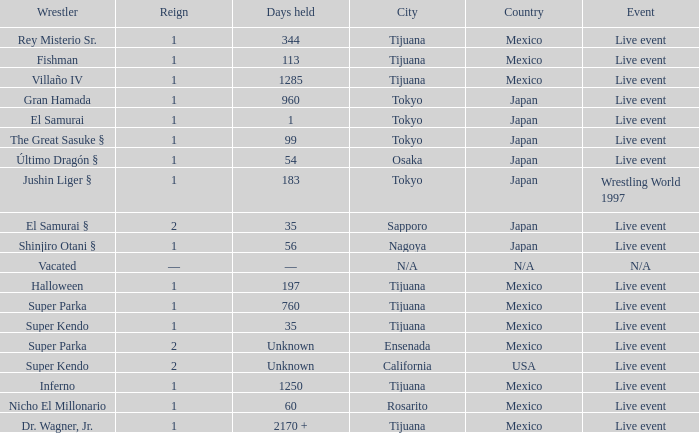Would you be able to parse every entry in this table? {'header': ['Wrestler', 'Reign', 'Days held', 'City', 'Country', 'Event'], 'rows': [['Rey Misterio Sr.', '1', '344', 'Tijuana', 'Mexico', 'Live event'], ['Fishman', '1', '113', 'Tijuana', 'Mexico', 'Live event'], ['Villaño IV', '1', '1285', 'Tijuana', 'Mexico', 'Live event'], ['Gran Hamada', '1', '960', 'Tokyo', 'Japan', 'Live event'], ['El Samurai', '1', '1', 'Tokyo', 'Japan', 'Live event'], ['The Great Sasuke §', '1', '99', 'Tokyo', 'Japan', 'Live event'], ['Último Dragón §', '1', '54', 'Osaka', 'Japan', 'Live event'], ['Jushin Liger §', '1', '183', 'Tokyo', 'Japan', 'Wrestling World 1997'], ['El Samurai §', '2', '35', 'Sapporo', 'Japan', 'Live event'], ['Shinjiro Otani §', '1', '56', 'Nagoya', 'Japan', 'Live event'], ['Vacated', '—', '—', 'N/A', 'N/A', 'N/A'], ['Halloween', '1', '197', 'Tijuana', 'Mexico', 'Live event'], ['Super Parka', '1', '760', 'Tijuana', 'Mexico', 'Live event'], ['Super Kendo', '1', '35', 'Tijuana', 'Mexico', 'Live event'], ['Super Parka', '2', 'Unknown', 'Ensenada', 'Mexico', 'Live event'], ['Super Kendo', '2', 'Unknown', 'California', 'USA', 'Live event'], ['Inferno', '1', '1250', 'Tijuana', 'Mexico', 'Live event'], ['Nicho El Millonario', '1', '60', 'Rosarito', 'Mexico', 'Live event'], ['Dr. Wagner, Jr.', '1', '2170 +', 'Tijuana', 'Mexico', 'Live event']]} Where did the wrestler, super parka, with the title with a reign of 2? Ensenada, Baja California , Mexico. 